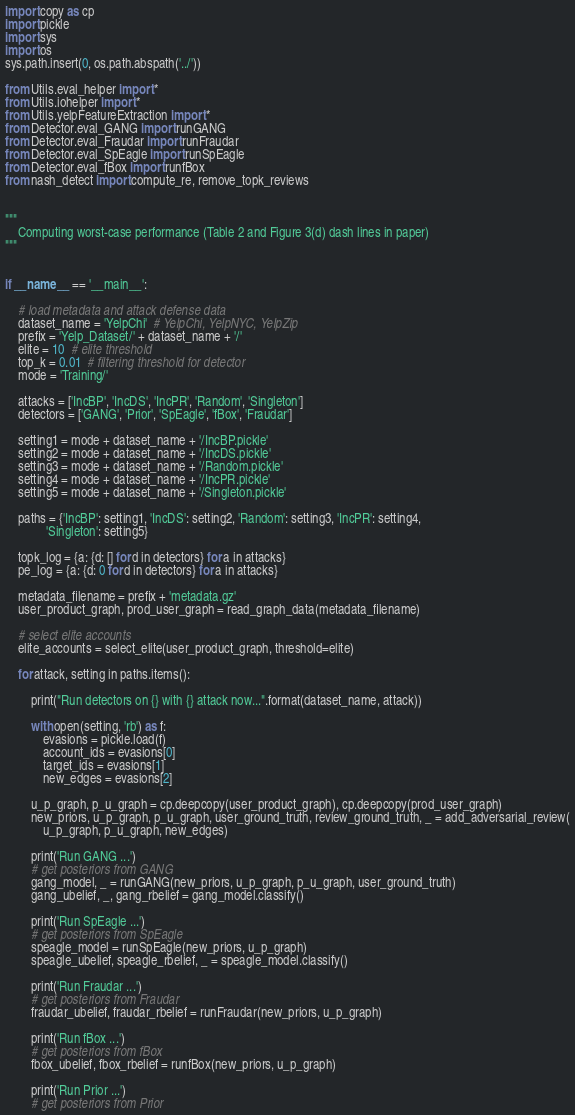Convert code to text. <code><loc_0><loc_0><loc_500><loc_500><_Python_>import copy as cp
import pickle
import sys
import os
sys.path.insert(0, os.path.abspath('../'))

from Utils.eval_helper import *
from Utils.iohelper import *
from Utils.yelpFeatureExtraction import *
from Detector.eval_GANG import runGANG
from Detector.eval_Fraudar import runFraudar
from Detector.eval_SpEagle import runSpEagle
from Detector.eval_fBox import runfBox
from nash_detect import compute_re, remove_topk_reviews


"""
	Computing worst-case performance (Table 2 and Figure 3(d) dash lines in paper)
"""


if __name__ == '__main__':

	# load metadata and attack defense data
	dataset_name = 'YelpChi'  # YelpChi, YelpNYC, YelpZip
	prefix = 'Yelp_Dataset/' + dataset_name + '/'
	elite = 10  # elite threshold
	top_k = 0.01  # filtering threshold for detector
	mode = 'Training/'

	attacks = ['IncBP', 'IncDS', 'IncPR', 'Random', 'Singleton']
	detectors = ['GANG', 'Prior', 'SpEagle', 'fBox', 'Fraudar']

	setting1 = mode + dataset_name + '/IncBP.pickle'
	setting2 = mode + dataset_name + '/IncDS.pickle'
	setting3 = mode + dataset_name + '/Random.pickle'
	setting4 = mode + dataset_name + '/IncPR.pickle'
	setting5 = mode + dataset_name + '/Singleton.pickle'

	paths = {'IncBP': setting1, 'IncDS': setting2, 'Random': setting3, 'IncPR': setting4,
			 'Singleton': setting5}

	topk_log = {a: {d: [] for d in detectors} for a in attacks}
	pe_log = {a: {d: 0 for d in detectors} for a in attacks}

	metadata_filename = prefix + 'metadata.gz'
	user_product_graph, prod_user_graph = read_graph_data(metadata_filename)

	# select elite accounts
	elite_accounts = select_elite(user_product_graph, threshold=elite)

	for attack, setting in paths.items():

		print("Run detectors on {} with {} attack now...".format(dataset_name, attack))

		with open(setting, 'rb') as f:
			evasions = pickle.load(f)
			account_ids = evasions[0]
			target_ids = evasions[1]
			new_edges = evasions[2]

		u_p_graph, p_u_graph = cp.deepcopy(user_product_graph), cp.deepcopy(prod_user_graph)
		new_priors, u_p_graph, p_u_graph, user_ground_truth, review_ground_truth, _ = add_adversarial_review(
			u_p_graph, p_u_graph, new_edges)

		print('Run GANG ...')
		# get posteriors from GANG
		gang_model, _ = runGANG(new_priors, u_p_graph, p_u_graph, user_ground_truth)
		gang_ubelief, _, gang_rbelief = gang_model.classify()

		print('Run SpEagle ...')
		# get posteriors from SpEagle
		speagle_model = runSpEagle(new_priors, u_p_graph)
		speagle_ubelief, speagle_rbelief, _ = speagle_model.classify()

		print('Run Fraudar ...')
		# get posteriors from Fraudar
		fraudar_ubelief, fraudar_rbelief = runFraudar(new_priors, u_p_graph)

		print('Run fBox ...')
		# get posteriors from fBox
		fbox_ubelief, fbox_rbelief = runfBox(new_priors, u_p_graph)

		print('Run Prior ...')
		# get posteriors from Prior</code> 